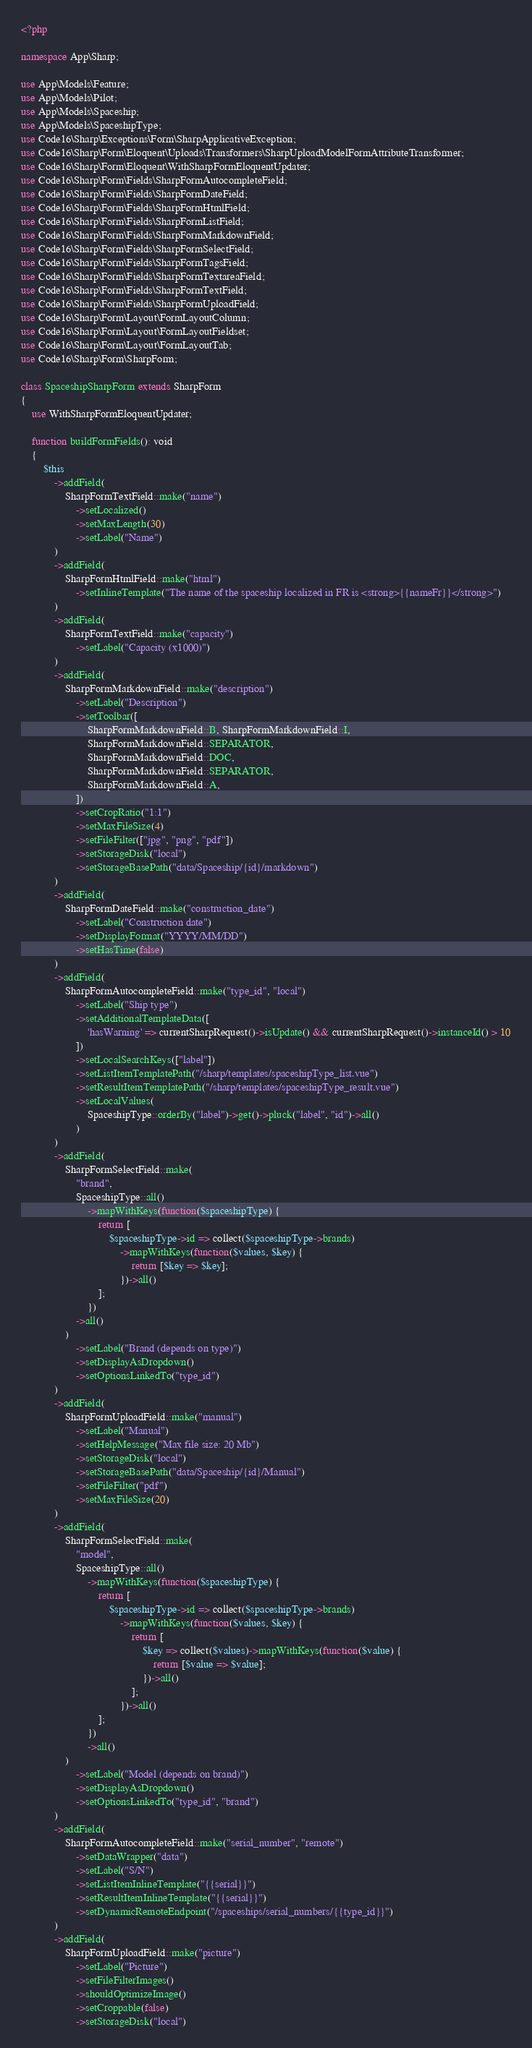Convert code to text. <code><loc_0><loc_0><loc_500><loc_500><_PHP_><?php

namespace App\Sharp;

use App\Models\Feature;
use App\Models\Pilot;
use App\Models\Spaceship;
use App\Models\SpaceshipType;
use Code16\Sharp\Exceptions\Form\SharpApplicativeException;
use Code16\Sharp\Form\Eloquent\Uploads\Transformers\SharpUploadModelFormAttributeTransformer;
use Code16\Sharp\Form\Eloquent\WithSharpFormEloquentUpdater;
use Code16\Sharp\Form\Fields\SharpFormAutocompleteField;
use Code16\Sharp\Form\Fields\SharpFormDateField;
use Code16\Sharp\Form\Fields\SharpFormHtmlField;
use Code16\Sharp\Form\Fields\SharpFormListField;
use Code16\Sharp\Form\Fields\SharpFormMarkdownField;
use Code16\Sharp\Form\Fields\SharpFormSelectField;
use Code16\Sharp\Form\Fields\SharpFormTagsField;
use Code16\Sharp\Form\Fields\SharpFormTextareaField;
use Code16\Sharp\Form\Fields\SharpFormTextField;
use Code16\Sharp\Form\Fields\SharpFormUploadField;
use Code16\Sharp\Form\Layout\FormLayoutColumn;
use Code16\Sharp\Form\Layout\FormLayoutFieldset;
use Code16\Sharp\Form\Layout\FormLayoutTab;
use Code16\Sharp\Form\SharpForm;

class SpaceshipSharpForm extends SharpForm
{
    use WithSharpFormEloquentUpdater;

    function buildFormFields(): void
    {
        $this
            ->addField(
                SharpFormTextField::make("name")
                    ->setLocalized()
                    ->setMaxLength(30)
                    ->setLabel("Name")
            )
            ->addField(
                SharpFormHtmlField::make("html")
                    ->setInlineTemplate("The name of the spaceship localized in FR is <strong>{{nameFr}}</strong>")
            )
            ->addField(
                SharpFormTextField::make("capacity")
                    ->setLabel("Capacity (x1000)")
            )
            ->addField(
                SharpFormMarkdownField::make("description")
                    ->setLabel("Description")
                    ->setToolbar([
                        SharpFormMarkdownField::B, SharpFormMarkdownField::I,
                        SharpFormMarkdownField::SEPARATOR,
                        SharpFormMarkdownField::DOC,
                        SharpFormMarkdownField::SEPARATOR,
                        SharpFormMarkdownField::A,
                    ])
                    ->setCropRatio("1:1")
                    ->setMaxFileSize(4)
                    ->setFileFilter(["jpg", "png", "pdf"])
                    ->setStorageDisk("local")
                    ->setStorageBasePath("data/Spaceship/{id}/markdown")
            )
            ->addField(
                SharpFormDateField::make("construction_date")
                    ->setLabel("Construction date")
                    ->setDisplayFormat("YYYY/MM/DD")
                    ->setHasTime(false)
            )
            ->addField(
                SharpFormAutocompleteField::make("type_id", "local")
                    ->setLabel("Ship type")
                    ->setAdditionalTemplateData([
                        'hasWarning' => currentSharpRequest()->isUpdate() && currentSharpRequest()->instanceId() > 10
                    ])
                    ->setLocalSearchKeys(["label"])
                    ->setListItemTemplatePath("/sharp/templates/spaceshipType_list.vue")
                    ->setResultItemTemplatePath("/sharp/templates/spaceshipType_result.vue")
                    ->setLocalValues(
                        SpaceshipType::orderBy("label")->get()->pluck("label", "id")->all()
                    )
            )
            ->addField(
                SharpFormSelectField::make(
                    "brand",
                    SpaceshipType::all()
                        ->mapWithKeys(function($spaceshipType) {
                            return [
                                $spaceshipType->id => collect($spaceshipType->brands)
                                    ->mapWithKeys(function($values, $key) {
                                        return [$key => $key];
                                    })->all()
                            ];
                        })
                    ->all()
                )
                    ->setLabel("Brand (depends on type)")
                    ->setDisplayAsDropdown()
                    ->setOptionsLinkedTo("type_id")
            )
            ->addField(
                SharpFormUploadField::make("manual")
                    ->setLabel("Manual")
                    ->setHelpMessage("Max file size: 20 Mb")
                    ->setStorageDisk("local")
                    ->setStorageBasePath("data/Spaceship/{id}/Manual")
                    ->setFileFilter("pdf")
                    ->setMaxFileSize(20)
            )
            ->addField(
                SharpFormSelectField::make(
                    "model",
                    SpaceshipType::all()
                        ->mapWithKeys(function($spaceshipType) {
                            return [
                                $spaceshipType->id => collect($spaceshipType->brands)
                                    ->mapWithKeys(function($values, $key) {
                                        return [
                                            $key => collect($values)->mapWithKeys(function($value) {
                                                return [$value => $value];
                                            })->all()
                                        ];
                                    })->all()
                            ];
                        })
                        ->all()
                )
                    ->setLabel("Model (depends on brand)")
                    ->setDisplayAsDropdown()
                    ->setOptionsLinkedTo("type_id", "brand")
            )
            ->addField(
                SharpFormAutocompleteField::make("serial_number", "remote")
                    ->setDataWrapper("data")
                    ->setLabel("S/N")
                    ->setListItemInlineTemplate("{{serial}}")
                    ->setResultItemInlineTemplate("{{serial}}")
                    ->setDynamicRemoteEndpoint("/spaceships/serial_numbers/{{type_id}}")
            )
            ->addField(
                SharpFormUploadField::make("picture")
                    ->setLabel("Picture")
                    ->setFileFilterImages()
                    ->shouldOptimizeImage()
                    ->setCroppable(false)
                    ->setStorageDisk("local")</code> 